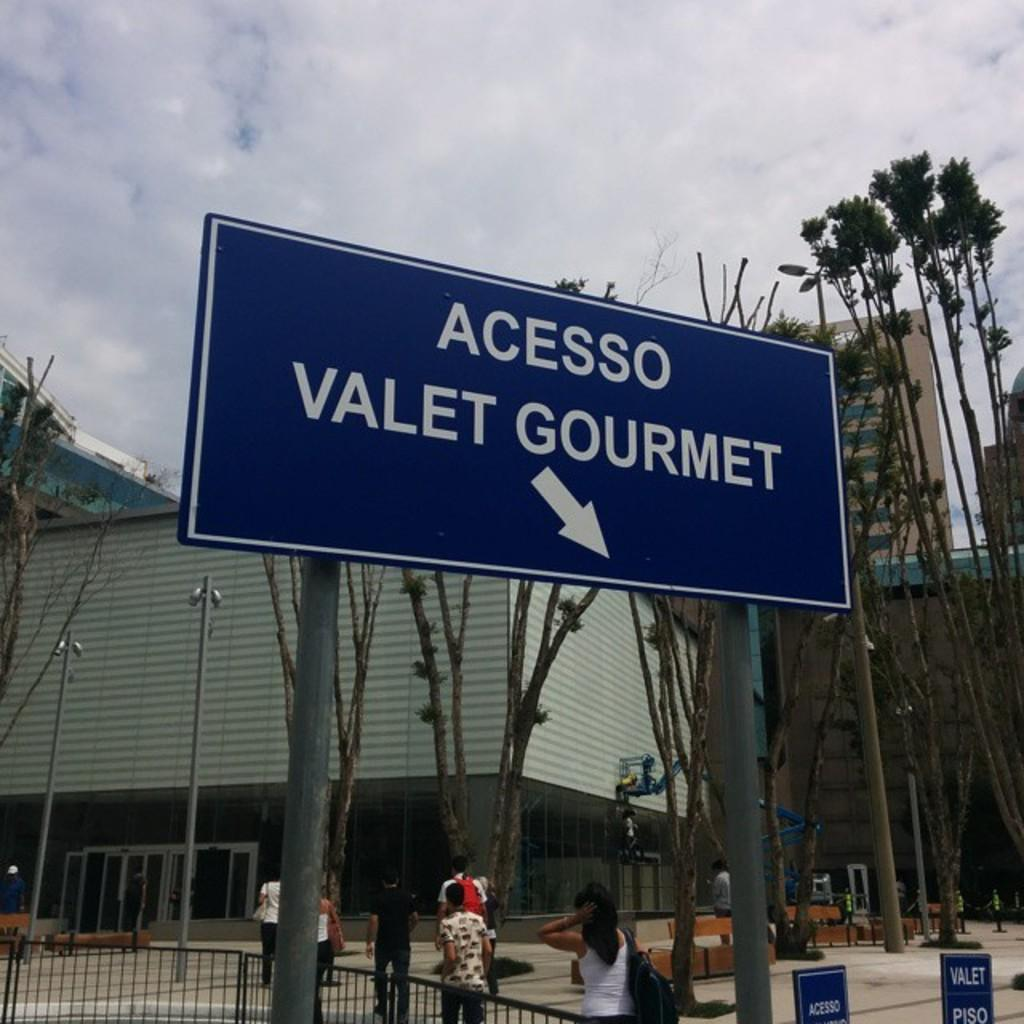<image>
Summarize the visual content of the image. A blue city street sign that points towards Acesso Valet Gourmet. 